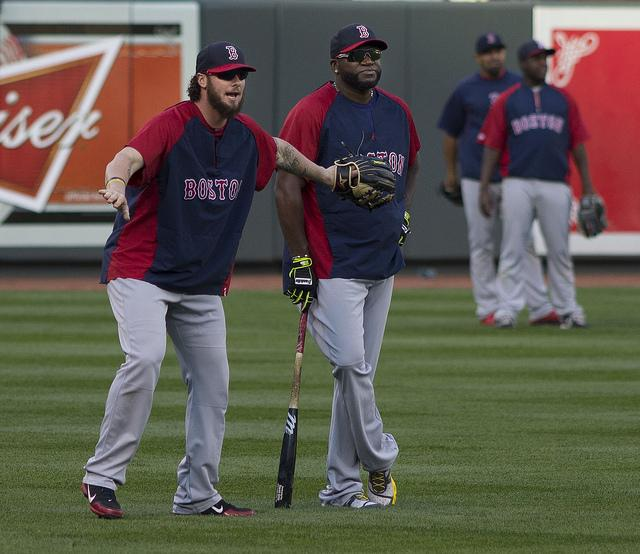What team do the men on the field play for? Please explain your reasoning. red sox. They play at fenway. 